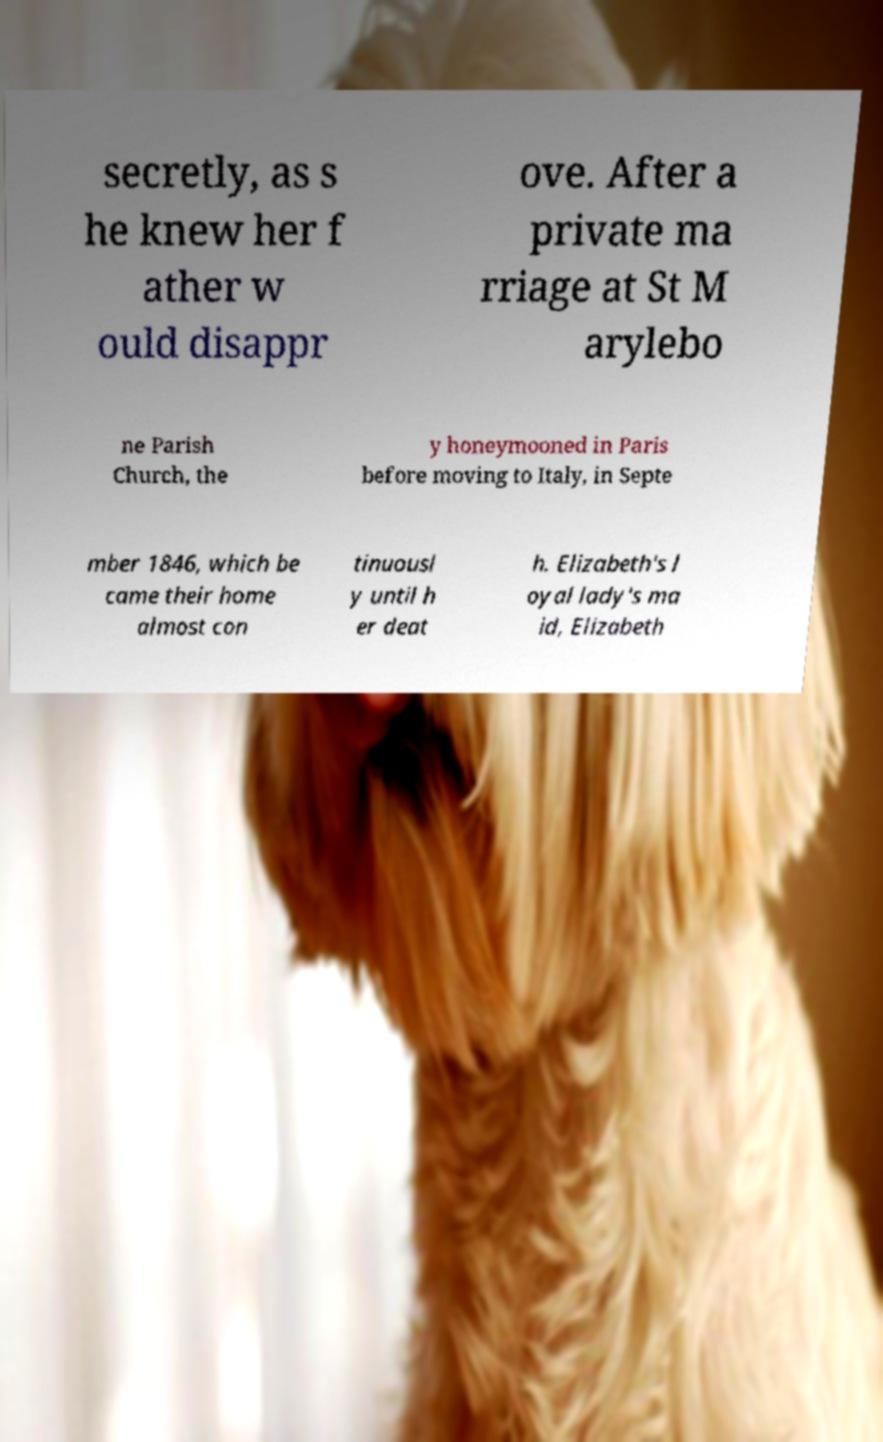Could you extract and type out the text from this image? secretly, as s he knew her f ather w ould disappr ove. After a private ma rriage at St M arylebo ne Parish Church, the y honeymooned in Paris before moving to Italy, in Septe mber 1846, which be came their home almost con tinuousl y until h er deat h. Elizabeth's l oyal lady's ma id, Elizabeth 